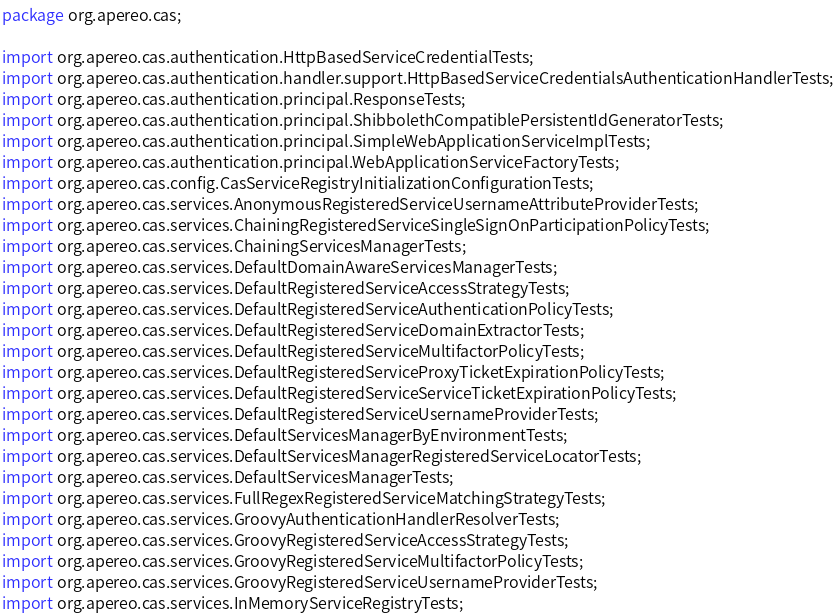<code> <loc_0><loc_0><loc_500><loc_500><_Java_>package org.apereo.cas;

import org.apereo.cas.authentication.HttpBasedServiceCredentialTests;
import org.apereo.cas.authentication.handler.support.HttpBasedServiceCredentialsAuthenticationHandlerTests;
import org.apereo.cas.authentication.principal.ResponseTests;
import org.apereo.cas.authentication.principal.ShibbolethCompatiblePersistentIdGeneratorTests;
import org.apereo.cas.authentication.principal.SimpleWebApplicationServiceImplTests;
import org.apereo.cas.authentication.principal.WebApplicationServiceFactoryTests;
import org.apereo.cas.config.CasServiceRegistryInitializationConfigurationTests;
import org.apereo.cas.services.AnonymousRegisteredServiceUsernameAttributeProviderTests;
import org.apereo.cas.services.ChainingRegisteredServiceSingleSignOnParticipationPolicyTests;
import org.apereo.cas.services.ChainingServicesManagerTests;
import org.apereo.cas.services.DefaultDomainAwareServicesManagerTests;
import org.apereo.cas.services.DefaultRegisteredServiceAccessStrategyTests;
import org.apereo.cas.services.DefaultRegisteredServiceAuthenticationPolicyTests;
import org.apereo.cas.services.DefaultRegisteredServiceDomainExtractorTests;
import org.apereo.cas.services.DefaultRegisteredServiceMultifactorPolicyTests;
import org.apereo.cas.services.DefaultRegisteredServiceProxyTicketExpirationPolicyTests;
import org.apereo.cas.services.DefaultRegisteredServiceServiceTicketExpirationPolicyTests;
import org.apereo.cas.services.DefaultRegisteredServiceUsernameProviderTests;
import org.apereo.cas.services.DefaultServicesManagerByEnvironmentTests;
import org.apereo.cas.services.DefaultServicesManagerRegisteredServiceLocatorTests;
import org.apereo.cas.services.DefaultServicesManagerTests;
import org.apereo.cas.services.FullRegexRegisteredServiceMatchingStrategyTests;
import org.apereo.cas.services.GroovyAuthenticationHandlerResolverTests;
import org.apereo.cas.services.GroovyRegisteredServiceAccessStrategyTests;
import org.apereo.cas.services.GroovyRegisteredServiceMultifactorPolicyTests;
import org.apereo.cas.services.GroovyRegisteredServiceUsernameProviderTests;
import org.apereo.cas.services.InMemoryServiceRegistryTests;</code> 